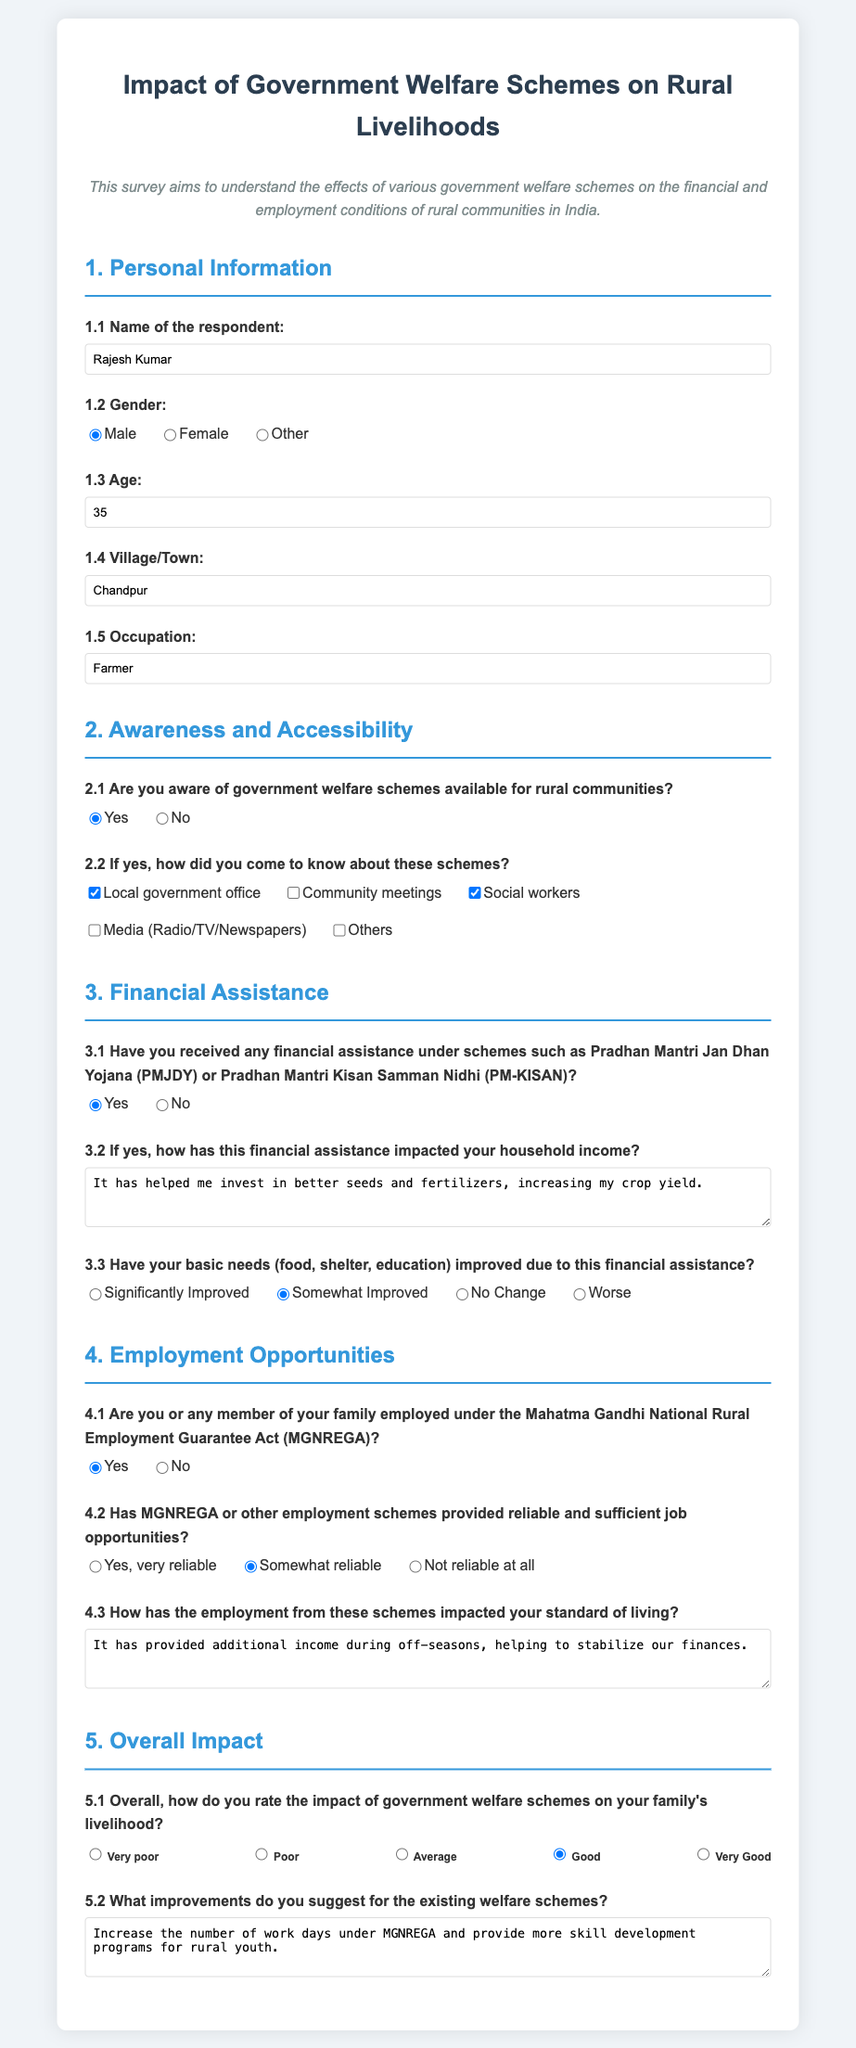What is the name of the respondent? The name of the respondent is provided in the personal information section.
Answer: Rajesh Kumar What is the age of the respondent? The age is stated under the personal information section.
Answer: 35 How did the respondent first learn about government welfare schemes? The sources of awareness are listed under the awareness and accessibility section.
Answer: Local government office, Social workers Has the respondent received any financial assistance? The response to whether financial assistance has been received is indicated in the financial assistance section.
Answer: Yes What impact did the financial assistance have on the household income? The respondent's view on the impact of financial assistance is detailed in the respective question under the financial assistance section.
Answer: It has helped me invest in better seeds and fertilizers, increasing my crop yield Are any family members employed under MGNREGA? The employment status related to MGNREGA is presented in the employment opportunities section.
Answer: Yes How reliable are the job opportunities provided by MGNREGA? Reliability of job opportunities is rated in a specific question under the employment opportunities section.
Answer: Somewhat reliable What is the overall rating of the impact of government welfare schemes on the family's livelihood? The overall impact is rated in the final section of the survey.
Answer: Good What improvements does the respondent suggest for existing welfare schemes? Suggestions for improvements are provided in the responses under the overall impact section.
Answer: Increase the number of work days under MGNREGA and provide more skill development programs for rural youth 